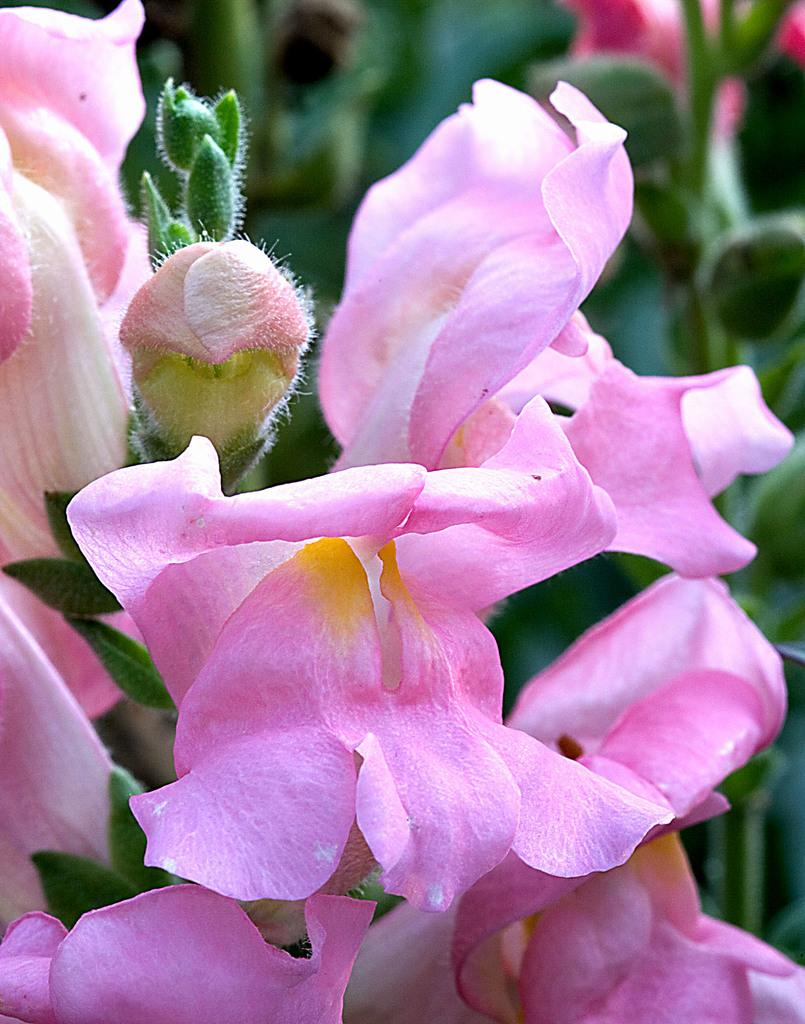What type of plants can be seen in the image? There are flowers in the image. What can be seen in the background of the image? There are leaves in the background of the image. What color is the crayon being used to draw on the arm in the image? There is no crayon or arm present in the image; it only features flowers and leaves. 